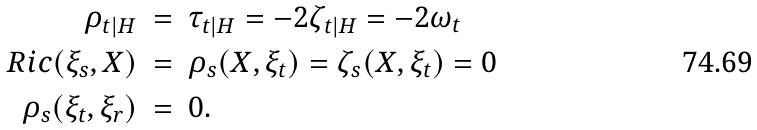Convert formula to latex. <formula><loc_0><loc_0><loc_500><loc_500>\rho _ { t | H } & \ = \ \tau _ { t | H } = - 2 \zeta _ { t | H } = - 2 \omega _ { t } \\ R i c ( \xi _ { s } , X ) & \ = \ \rho _ { s } ( X , \xi _ { t } ) = \zeta _ { s } ( X , \xi _ { t } ) = 0 \\ \rho _ { s } ( \xi _ { t } , \xi _ { r } ) & \ = \ 0 .</formula> 